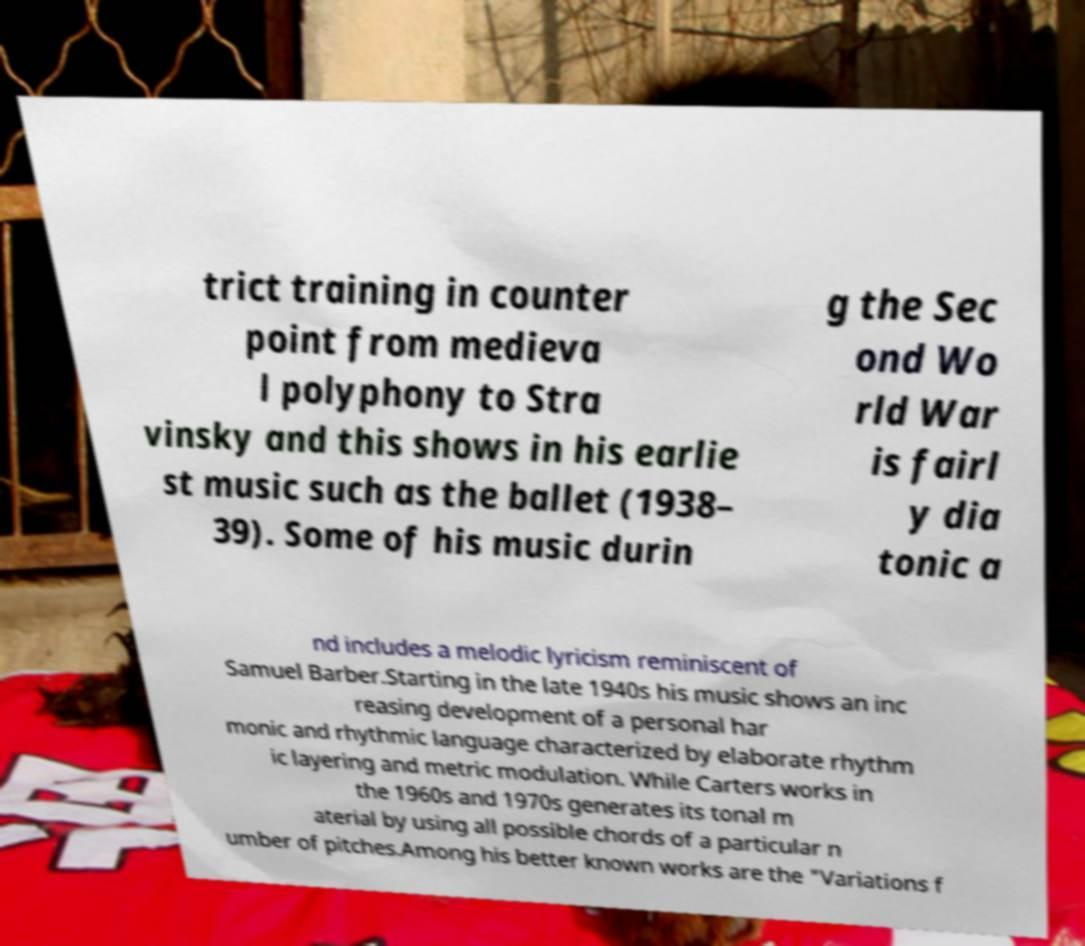Could you assist in decoding the text presented in this image and type it out clearly? trict training in counter point from medieva l polyphony to Stra vinsky and this shows in his earlie st music such as the ballet (1938– 39). Some of his music durin g the Sec ond Wo rld War is fairl y dia tonic a nd includes a melodic lyricism reminiscent of Samuel Barber.Starting in the late 1940s his music shows an inc reasing development of a personal har monic and rhythmic language characterized by elaborate rhythm ic layering and metric modulation. While Carters works in the 1960s and 1970s generates its tonal m aterial by using all possible chords of a particular n umber of pitches.Among his better known works are the "Variations f 